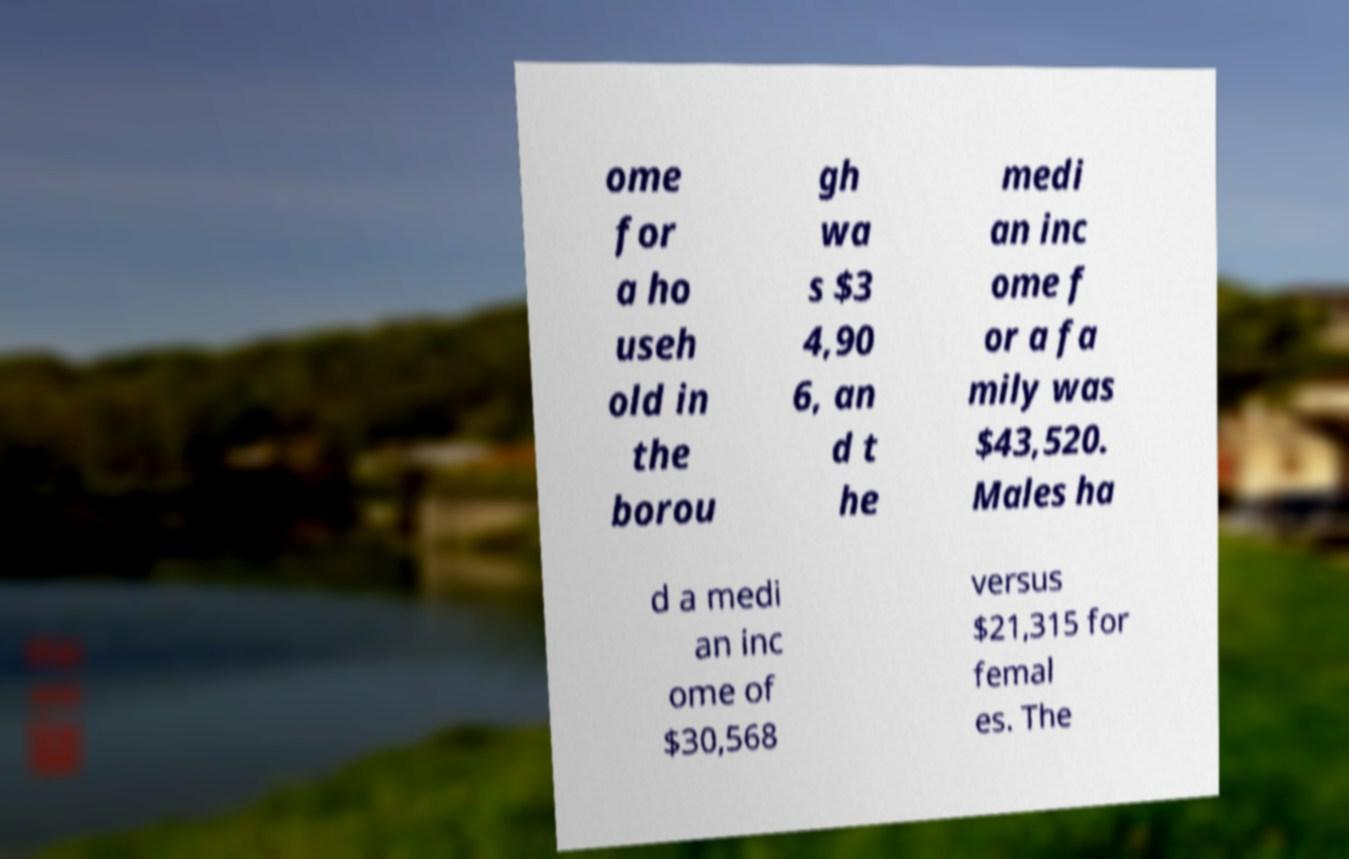There's text embedded in this image that I need extracted. Can you transcribe it verbatim? ome for a ho useh old in the borou gh wa s $3 4,90 6, an d t he medi an inc ome f or a fa mily was $43,520. Males ha d a medi an inc ome of $30,568 versus $21,315 for femal es. The 